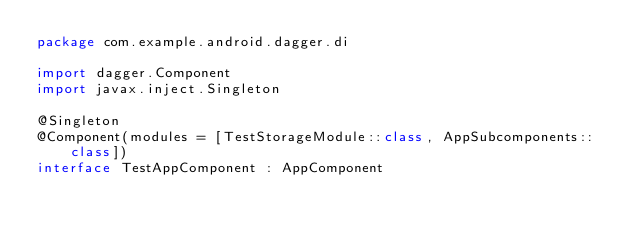<code> <loc_0><loc_0><loc_500><loc_500><_Kotlin_>package com.example.android.dagger.di

import dagger.Component
import javax.inject.Singleton

@Singleton
@Component(modules = [TestStorageModule::class, AppSubcomponents::class])
interface TestAppComponent : AppComponent</code> 